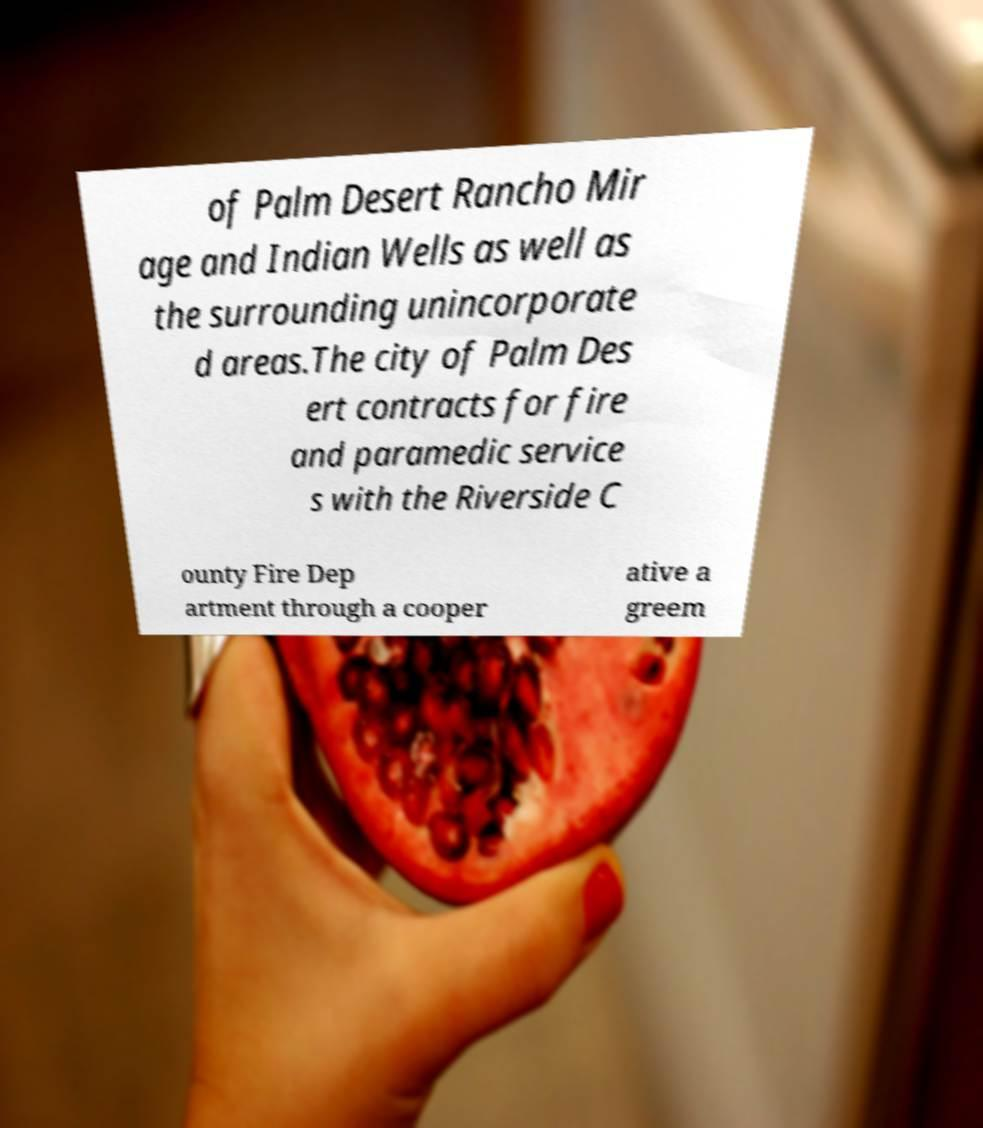I need the written content from this picture converted into text. Can you do that? of Palm Desert Rancho Mir age and Indian Wells as well as the surrounding unincorporate d areas.The city of Palm Des ert contracts for fire and paramedic service s with the Riverside C ounty Fire Dep artment through a cooper ative a greem 